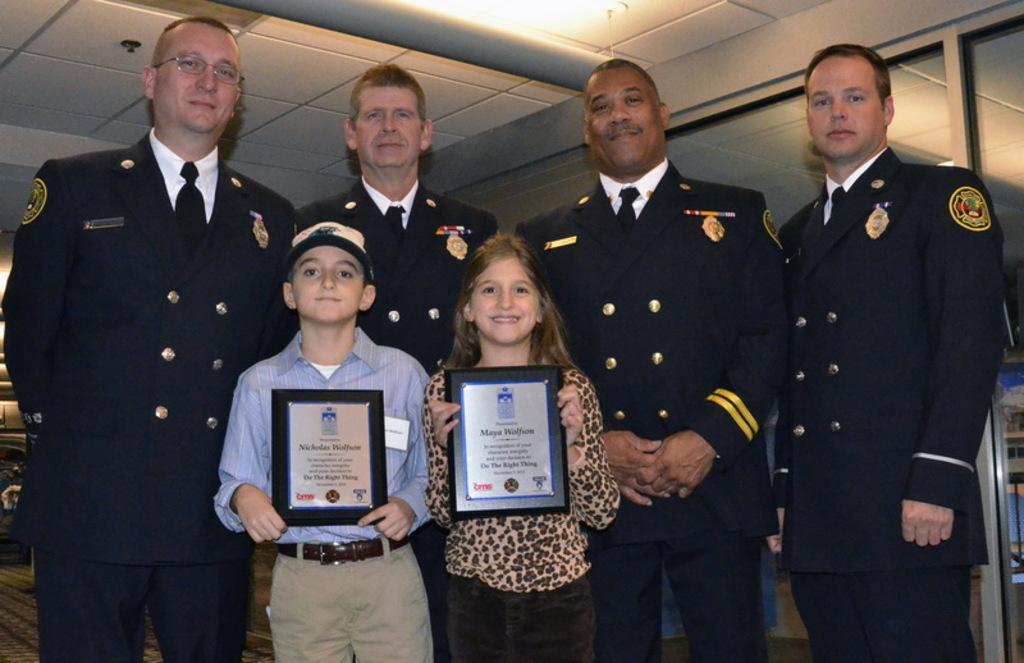What is happening in the image? There are people standing in the image, and some of them are children holding certificates. Can you describe the children in the image? The children in the image are holding certificates, which suggests they may have received an award or recognition. What type of shoe is the army using in the image? There is no army or shoe present in the image; it features people standing and children holding certificates. 